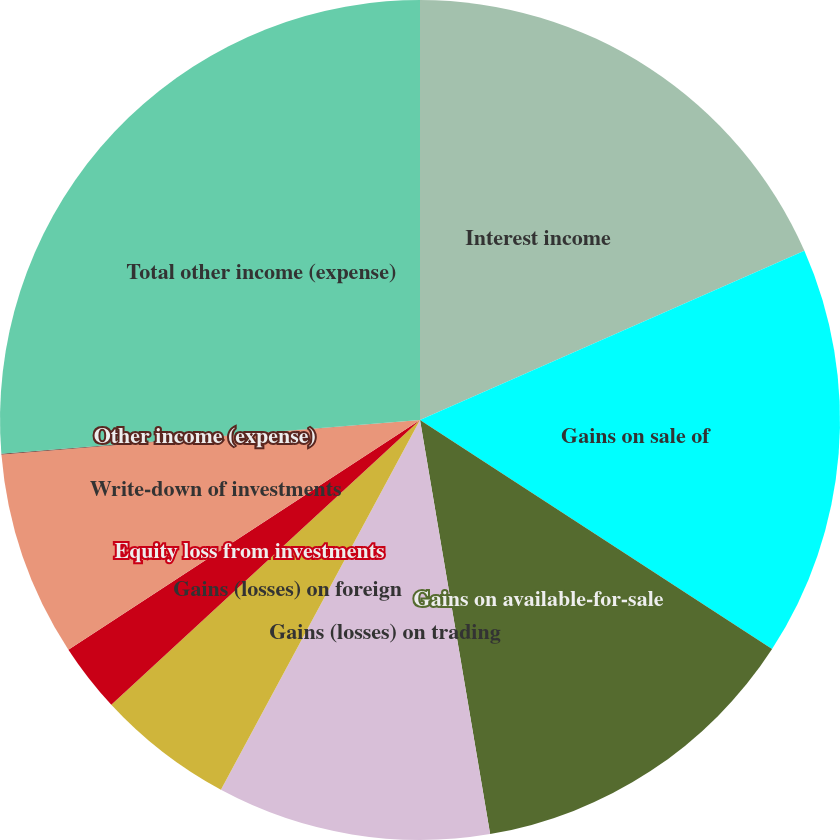Convert chart to OTSL. <chart><loc_0><loc_0><loc_500><loc_500><pie_chart><fcel>Interest income<fcel>Gains on sale of<fcel>Gains on available-for-sale<fcel>Gains (losses) on trading<fcel>Gains (losses) on foreign<fcel>Equity loss from investments<fcel>Write-down of investments<fcel>Other income (expense)<fcel>Total other income (expense)<nl><fcel>18.4%<fcel>15.78%<fcel>13.15%<fcel>10.53%<fcel>5.28%<fcel>2.65%<fcel>7.9%<fcel>0.03%<fcel>26.28%<nl></chart> 